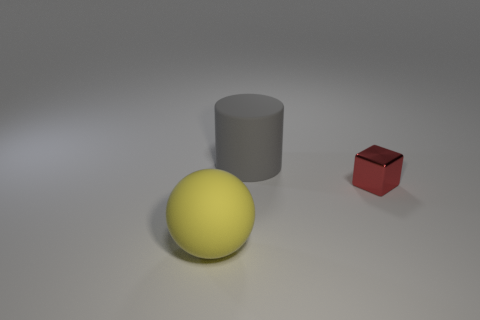Add 2 red cubes. How many objects exist? 5 Subtract all blocks. How many objects are left? 2 Subtract all red rubber things. Subtract all tiny metallic blocks. How many objects are left? 2 Add 3 metallic things. How many metallic things are left? 4 Add 3 tiny gray spheres. How many tiny gray spheres exist? 3 Subtract 0 blue blocks. How many objects are left? 3 